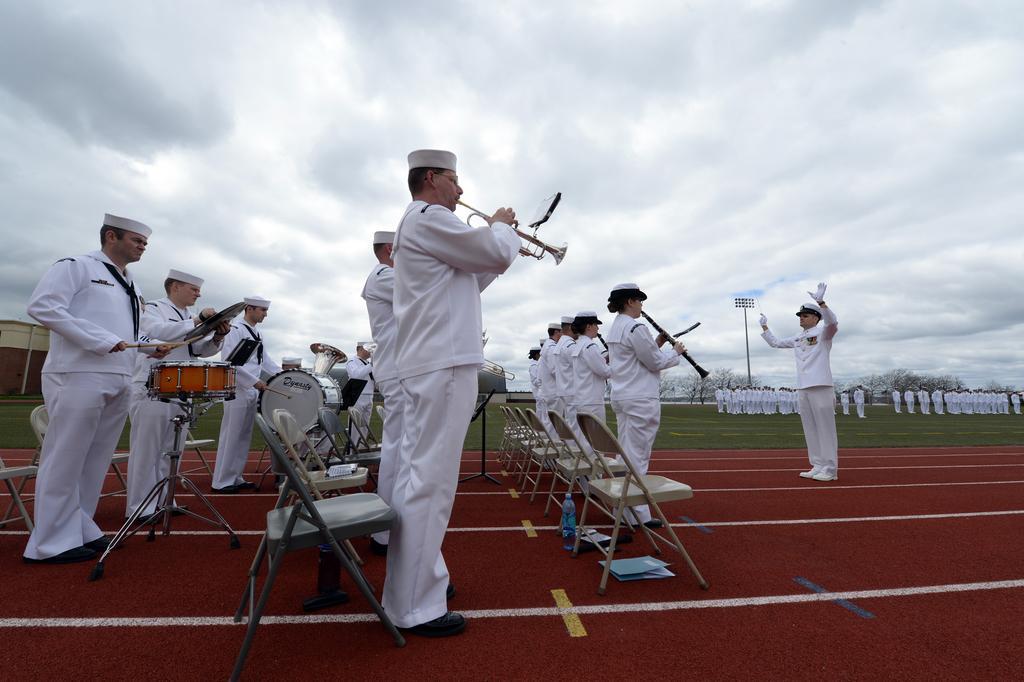How would you summarize this image in a sentence or two? In this picture there are several people dressed in white are playing musical instruments with chairs behind them and there is also a guy who is dressed in white and guiding these musicians. In the background there are many people dressed in white ,standing over there. 